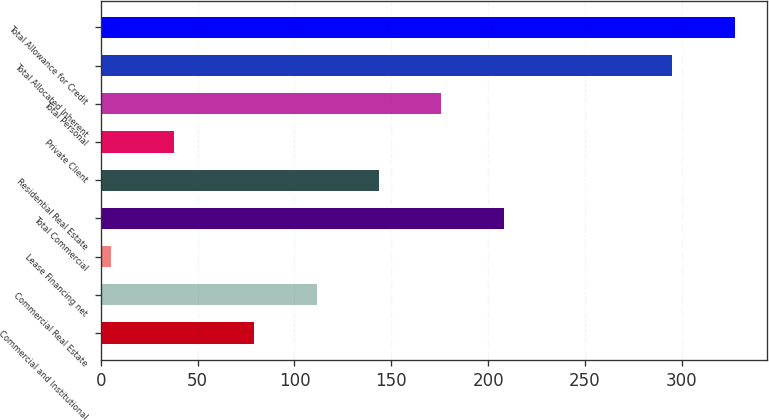Convert chart. <chart><loc_0><loc_0><loc_500><loc_500><bar_chart><fcel>Commercial and Institutional<fcel>Commercial Real Estate<fcel>Lease Financing net<fcel>Total Commercial<fcel>Residential Real Estate<fcel>Private Client<fcel>Total Personal<fcel>Total Allocated Inherent<fcel>Total Allowance for Credit<nl><fcel>79.2<fcel>111.41<fcel>5.5<fcel>208.04<fcel>143.62<fcel>37.71<fcel>175.83<fcel>295.1<fcel>327.6<nl></chart> 